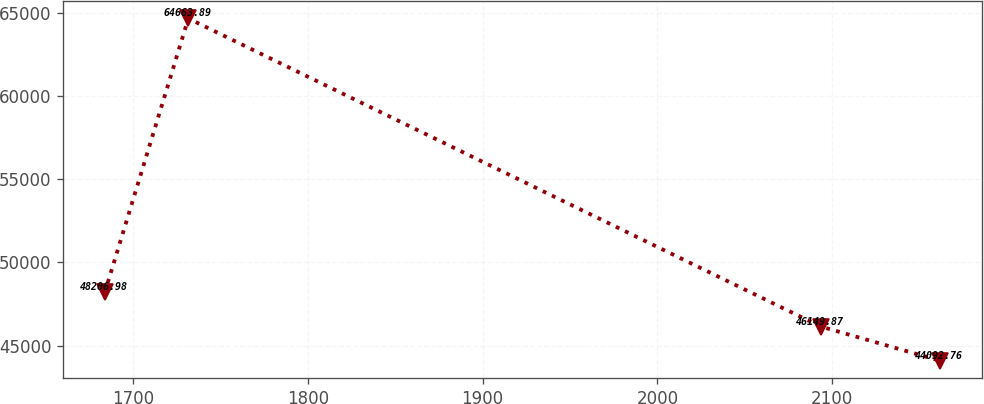Convert chart. <chart><loc_0><loc_0><loc_500><loc_500><line_chart><ecel><fcel>Unnamed: 1<nl><fcel>1683.94<fcel>48207<nl><fcel>1731.71<fcel>64663.9<nl><fcel>2093.42<fcel>46149.9<nl><fcel>2161.68<fcel>44092.8<nl></chart> 